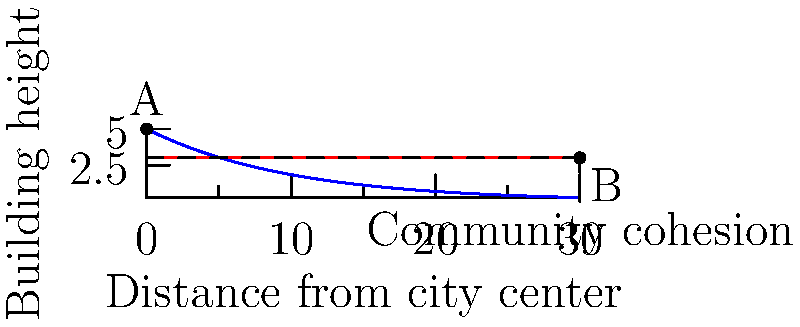In your latest play exploring urban development, you depict two contrasting skylines representing different building height policies. The blue curve shows a city with varying height restrictions, while the red line represents a city with uniform height limits. How might these different approaches to urban planning affect community cohesion, and which policy would you argue promotes stronger social bonds in your script? To analyze this scenario, let's consider the following steps:

1. Interpretation of the graph:
   - The blue curve (varying height restrictions) shows taller buildings near the city center (point A) that gradually decrease in height towards the outskirts.
   - The red line (uniform height restrictions) shows consistent building heights across the city.

2. Impact on community layout:
   - Varying heights (blue) create a more diverse urban landscape, potentially leading to distinct neighborhoods and local identities.
   - Uniform heights (red) promote a more homogeneous cityscape, which might foster a sense of equality among residents.

3. Social interaction patterns:
   - Varying heights may concentrate activities in the city center, potentially creating a vibrant core but possibly isolating outer areas.
   - Uniform heights could distribute activities more evenly, encouraging interactions across the entire city.

4. Economic factors:
   - Varying heights might lead to economic segregation, with premium spaces in taller, central buildings.
   - Uniform heights could promote more balanced economic development throughout the city.

5. Visual and psychological effects:
   - Varying heights create a dynamic skyline, which might inspire pride but could also feel overwhelming.
   - Uniform heights offer a sense of order and consistency, which might feel calming but potentially monotonous.

6. Community cohesion analysis:
   - Varying heights might strengthen local community bonds within distinct neighborhoods but could weaken city-wide cohesion.
   - Uniform heights might promote a more unified city identity and potentially stronger overall cohesion.

7. Sociological perspective:
   - The varying height model aligns with concepts of urban ecology and natural area theory, where different social groups gravitate to specific areas.
   - The uniform height model resonates with ideas of spatial equality and might reduce physical barriers to social mixing.

In a theatrical context, the playwright might argue that the uniform height restrictions (red line) promote stronger social bonds overall. This policy creates a more egalitarian urban environment, potentially reducing spatial segregation and encouraging interactions across diverse groups throughout the city. The consistent skyline could symbolize a shared urban identity and equal access to resources, fostering a sense of community that transcends neighborhood boundaries.
Answer: Uniform height restrictions promote stronger social bonds by creating an egalitarian urban environment that encourages city-wide interactions and a shared identity. 